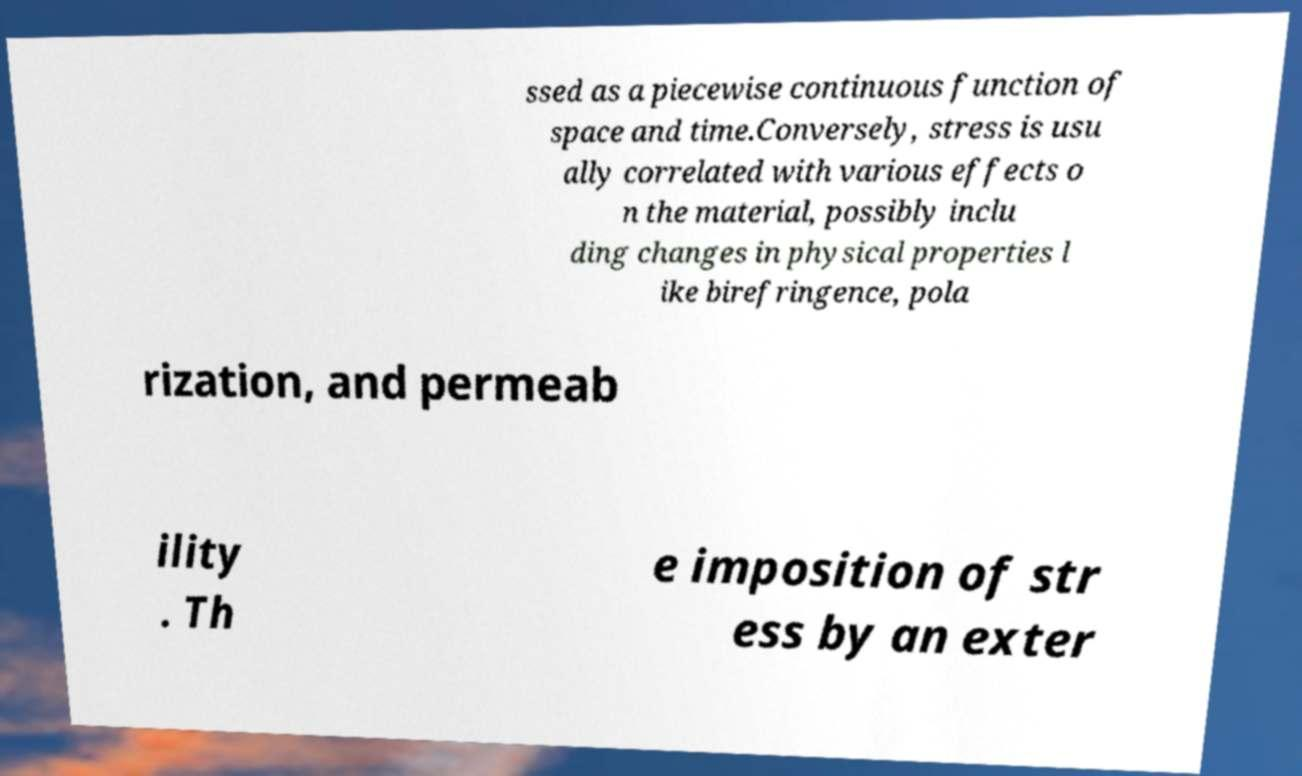For documentation purposes, I need the text within this image transcribed. Could you provide that? ssed as a piecewise continuous function of space and time.Conversely, stress is usu ally correlated with various effects o n the material, possibly inclu ding changes in physical properties l ike birefringence, pola rization, and permeab ility . Th e imposition of str ess by an exter 